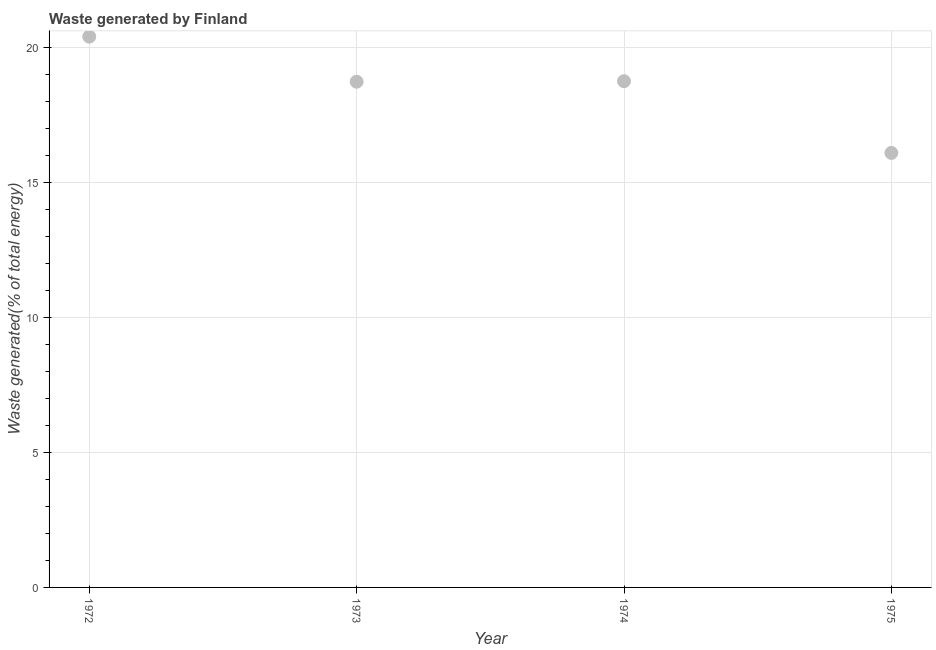What is the amount of waste generated in 1973?
Give a very brief answer. 18.74. Across all years, what is the maximum amount of waste generated?
Your response must be concise. 20.41. Across all years, what is the minimum amount of waste generated?
Offer a terse response. 16.1. In which year was the amount of waste generated minimum?
Give a very brief answer. 1975. What is the sum of the amount of waste generated?
Offer a very short reply. 74.01. What is the difference between the amount of waste generated in 1974 and 1975?
Your response must be concise. 2.66. What is the average amount of waste generated per year?
Provide a short and direct response. 18.5. What is the median amount of waste generated?
Your response must be concise. 18.75. In how many years, is the amount of waste generated greater than 18 %?
Your answer should be compact. 3. Do a majority of the years between 1975 and 1972 (inclusive) have amount of waste generated greater than 4 %?
Keep it short and to the point. Yes. What is the ratio of the amount of waste generated in 1973 to that in 1974?
Provide a succinct answer. 1. Is the amount of waste generated in 1974 less than that in 1975?
Your answer should be compact. No. Is the difference between the amount of waste generated in 1973 and 1974 greater than the difference between any two years?
Your answer should be compact. No. What is the difference between the highest and the second highest amount of waste generated?
Offer a terse response. 1.65. Is the sum of the amount of waste generated in 1972 and 1973 greater than the maximum amount of waste generated across all years?
Your response must be concise. Yes. What is the difference between the highest and the lowest amount of waste generated?
Your answer should be compact. 4.31. Does the amount of waste generated monotonically increase over the years?
Ensure brevity in your answer.  No. What is the difference between two consecutive major ticks on the Y-axis?
Your answer should be very brief. 5. Does the graph contain grids?
Give a very brief answer. Yes. What is the title of the graph?
Provide a short and direct response. Waste generated by Finland. What is the label or title of the Y-axis?
Your response must be concise. Waste generated(% of total energy). What is the Waste generated(% of total energy) in 1972?
Offer a terse response. 20.41. What is the Waste generated(% of total energy) in 1973?
Keep it short and to the point. 18.74. What is the Waste generated(% of total energy) in 1974?
Give a very brief answer. 18.76. What is the Waste generated(% of total energy) in 1975?
Make the answer very short. 16.1. What is the difference between the Waste generated(% of total energy) in 1972 and 1973?
Your answer should be very brief. 1.67. What is the difference between the Waste generated(% of total energy) in 1972 and 1974?
Make the answer very short. 1.65. What is the difference between the Waste generated(% of total energy) in 1972 and 1975?
Offer a very short reply. 4.31. What is the difference between the Waste generated(% of total energy) in 1973 and 1974?
Offer a terse response. -0.02. What is the difference between the Waste generated(% of total energy) in 1973 and 1975?
Offer a terse response. 2.64. What is the difference between the Waste generated(% of total energy) in 1974 and 1975?
Your answer should be compact. 2.66. What is the ratio of the Waste generated(% of total energy) in 1972 to that in 1973?
Provide a succinct answer. 1.09. What is the ratio of the Waste generated(% of total energy) in 1972 to that in 1974?
Make the answer very short. 1.09. What is the ratio of the Waste generated(% of total energy) in 1972 to that in 1975?
Offer a very short reply. 1.27. What is the ratio of the Waste generated(% of total energy) in 1973 to that in 1974?
Make the answer very short. 1. What is the ratio of the Waste generated(% of total energy) in 1973 to that in 1975?
Your response must be concise. 1.16. What is the ratio of the Waste generated(% of total energy) in 1974 to that in 1975?
Offer a very short reply. 1.17. 